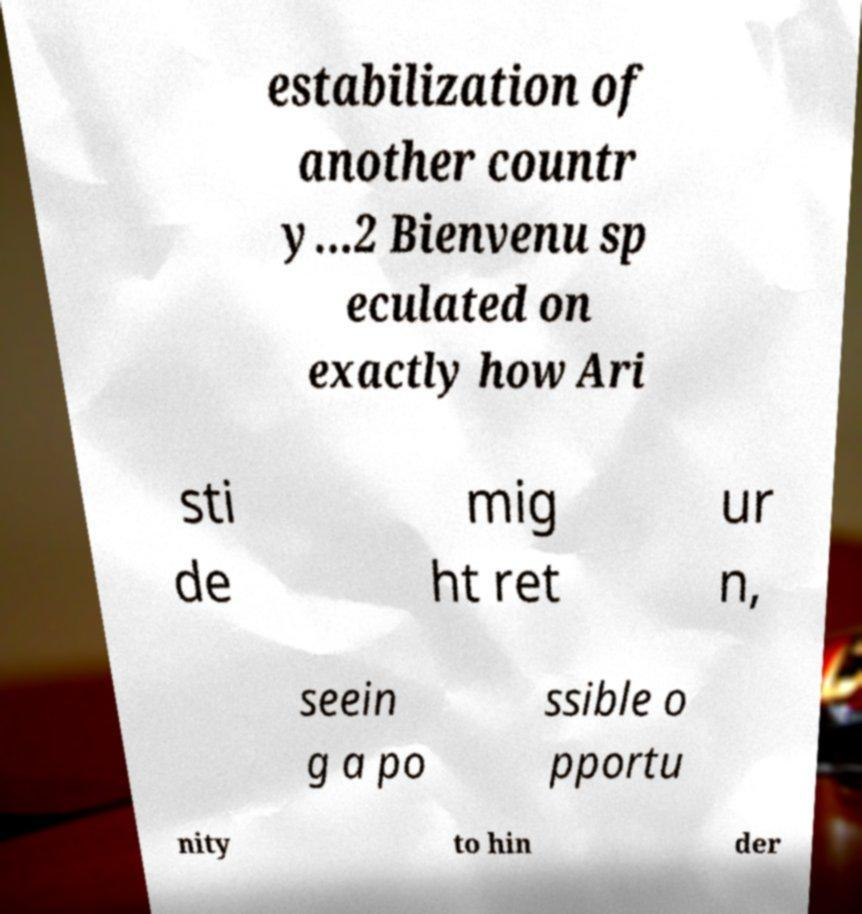Could you extract and type out the text from this image? estabilization of another countr y...2 Bienvenu sp eculated on exactly how Ari sti de mig ht ret ur n, seein g a po ssible o pportu nity to hin der 